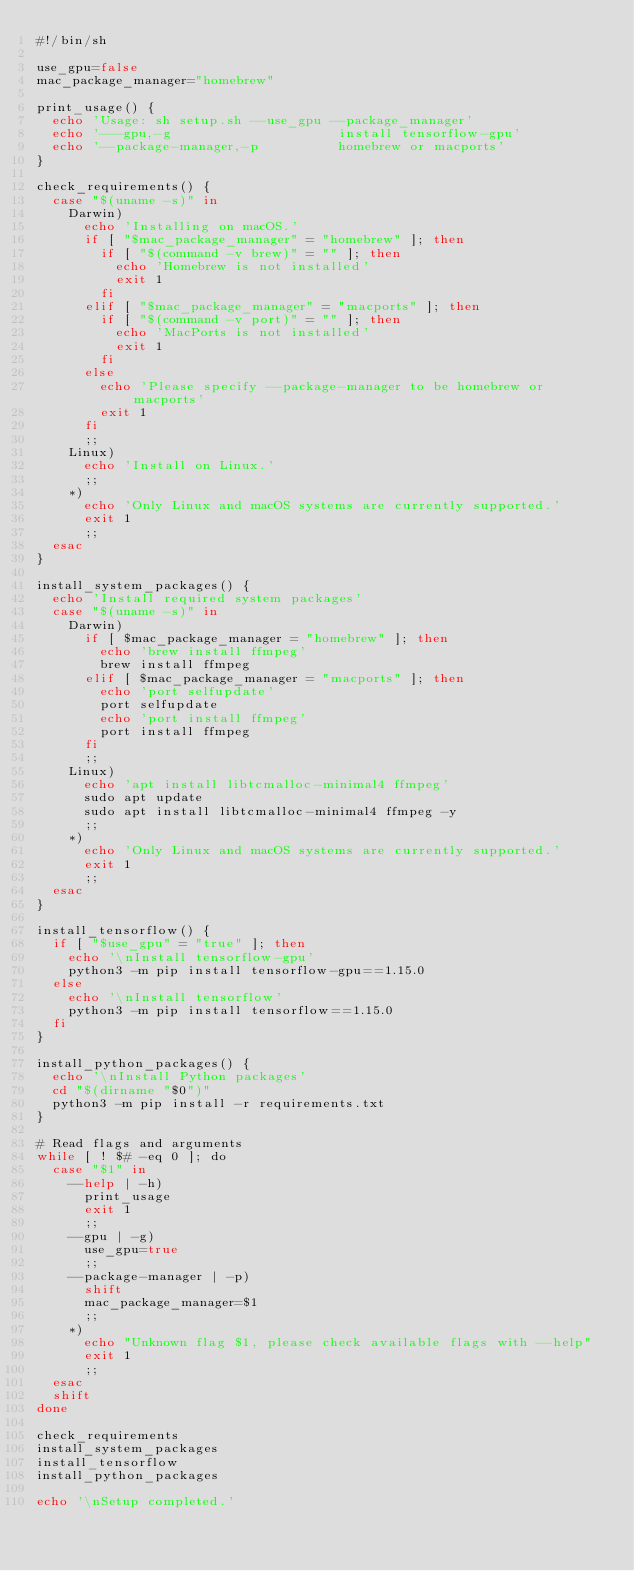<code> <loc_0><loc_0><loc_500><loc_500><_Bash_>#!/bin/sh

use_gpu=false
mac_package_manager="homebrew"

print_usage() {
  echo 'Usage: sh setup.sh --use_gpu --package_manager'
  echo '---gpu,-g                     install tensorflow-gpu'
  echo '--package-manager,-p          homebrew or macports'
}

check_requirements() {
  case "$(uname -s)" in
    Darwin)
      echo 'Installing on macOS.'
      if [ "$mac_package_manager" = "homebrew" ]; then
        if [ "$(command -v brew)" = "" ]; then
          echo 'Homebrew is not installed'
          exit 1
        fi
      elif [ "$mac_package_manager" = "macports" ]; then
        if [ "$(command -v port)" = "" ]; then
          echo 'MacPorts is not installed'
          exit 1
        fi
      else
        echo 'Please specify --package-manager to be homebrew or macports'
        exit 1
      fi
      ;;
    Linux)
      echo 'Install on Linux.'
      ;;
    *)
      echo 'Only Linux and macOS systems are currently supported.'
      exit 1
      ;;
  esac
}

install_system_packages() {
  echo 'Install required system packages'
  case "$(uname -s)" in
    Darwin)
      if [ $mac_package_manager = "homebrew" ]; then
        echo 'brew install ffmpeg'
        brew install ffmpeg
      elif [ $mac_package_manager = "macports" ]; then
        echo 'port selfupdate'
        port selfupdate
        echo 'port install ffmpeg'
        port install ffmpeg
      fi
      ;;
    Linux)
      echo 'apt install libtcmalloc-minimal4 ffmpeg'
      sudo apt update
      sudo apt install libtcmalloc-minimal4 ffmpeg -y
      ;;
    *)
      echo 'Only Linux and macOS systems are currently supported.'
      exit 1
      ;;
  esac
}

install_tensorflow() {
  if [ "$use_gpu" = "true" ]; then
    echo '\nInstall tensorflow-gpu'
    python3 -m pip install tensorflow-gpu==1.15.0
  else
    echo '\nInstall tensorflow'
    python3 -m pip install tensorflow==1.15.0
  fi
}

install_python_packages() {
  echo '\nInstall Python packages'
  cd "$(dirname "$0")"
  python3 -m pip install -r requirements.txt
}

# Read flags and arguments
while [ ! $# -eq 0 ]; do
  case "$1" in
    --help | -h)
      print_usage
      exit 1
      ;;
    --gpu | -g)
      use_gpu=true
      ;;
    --package-manager | -p)
      shift
      mac_package_manager=$1
      ;;
    *)
      echo "Unknown flag $1, please check available flags with --help"
      exit 1
      ;;
  esac
  shift
done

check_requirements
install_system_packages
install_tensorflow
install_python_packages

echo '\nSetup completed.'
</code> 